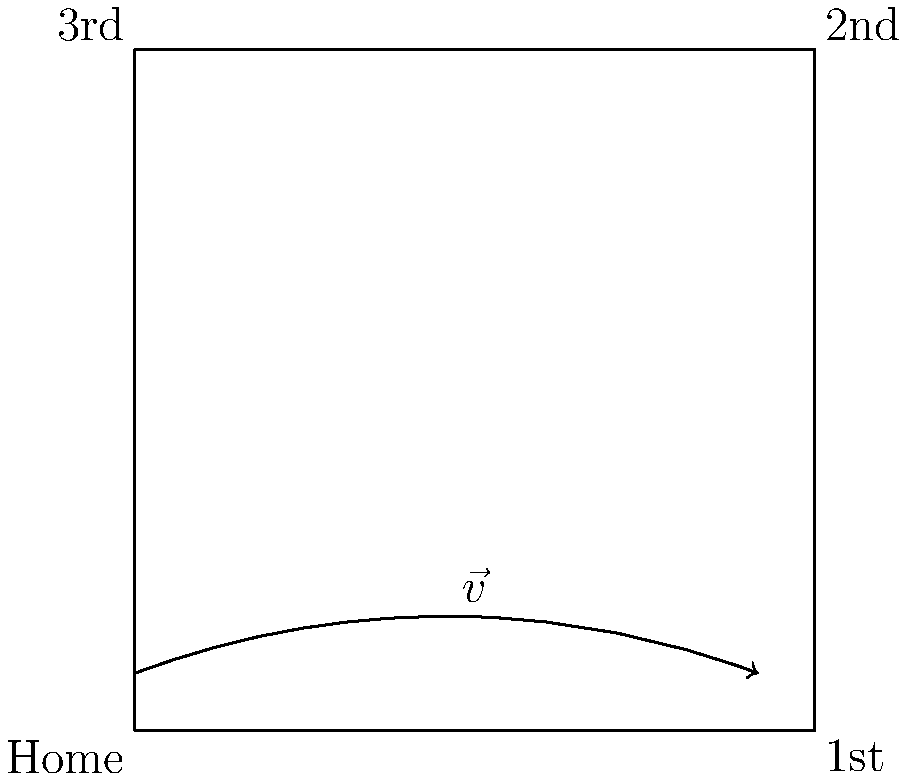As a former college baseball player, consider a baserunner's path from home plate to first base as shown in the diagram. If the vector $\vec{v}$ represents the runner's displacement, what is the magnitude of the runner's displacement in feet, given that the distance between bases is 90 feet? To solve this problem, let's follow these steps:

1) First, recall that the baseball diamond is a square, with each side measuring 90 feet.

2) The vector $\vec{v}$ represents the displacement of the runner from home plate to first base.

3) In a vector diagram, displacement is represented by a straight line from the starting point to the endpoint, regardless of the actual path taken.

4) In this case, the displacement vector $\vec{v}$ is simply the straight line from home plate to first base.

5) Since the baseball diamond is a square, this straight line forms the hypotenuse of a right triangle.

6) The length of this hypotenuse (which is the magnitude of the displacement vector) can be calculated using the Pythagorean theorem:

   $$|\vec{v}| = \sqrt{90^2 + 90^2}$$

7) Simplify:
   $$|\vec{v}| = \sqrt{8100 + 8100} = \sqrt{16200}$$

8) Calculate the square root:
   $$|\vec{v}| = 90\sqrt{2} \approx 127.28$$

Therefore, the magnitude of the runner's displacement is $90\sqrt{2}$ feet, or approximately 127.28 feet.
Answer: $90\sqrt{2}$ feet 